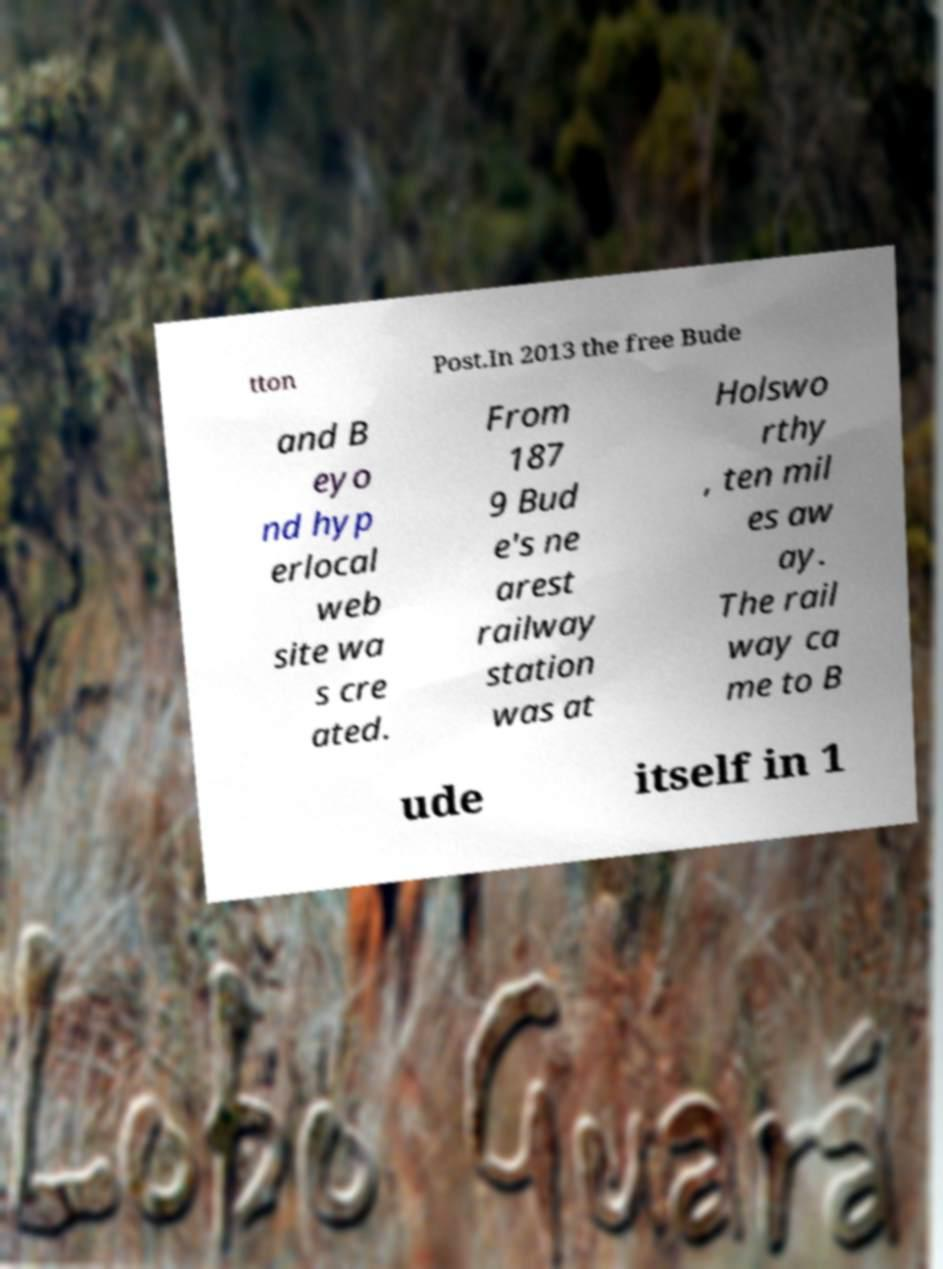Please read and relay the text visible in this image. What does it say? tton Post.In 2013 the free Bude and B eyo nd hyp erlocal web site wa s cre ated. From 187 9 Bud e's ne arest railway station was at Holswo rthy , ten mil es aw ay. The rail way ca me to B ude itself in 1 